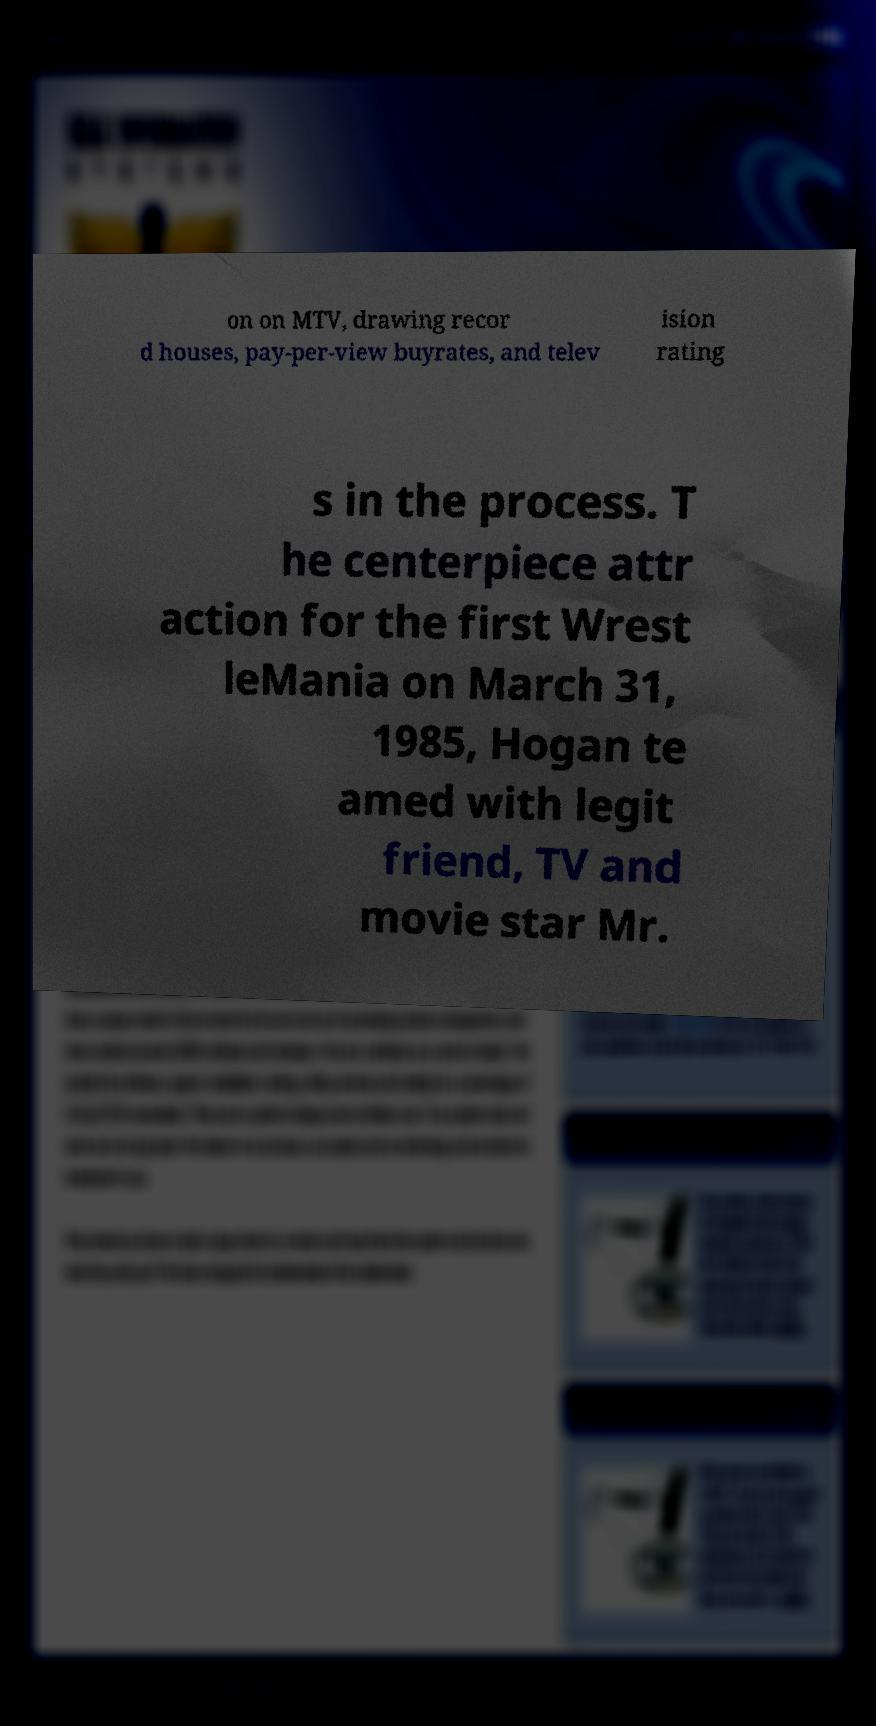I need the written content from this picture converted into text. Can you do that? on on MTV, drawing recor d houses, pay-per-view buyrates, and telev ision rating s in the process. T he centerpiece attr action for the first Wrest leMania on March 31, 1985, Hogan te amed with legit friend, TV and movie star Mr. 